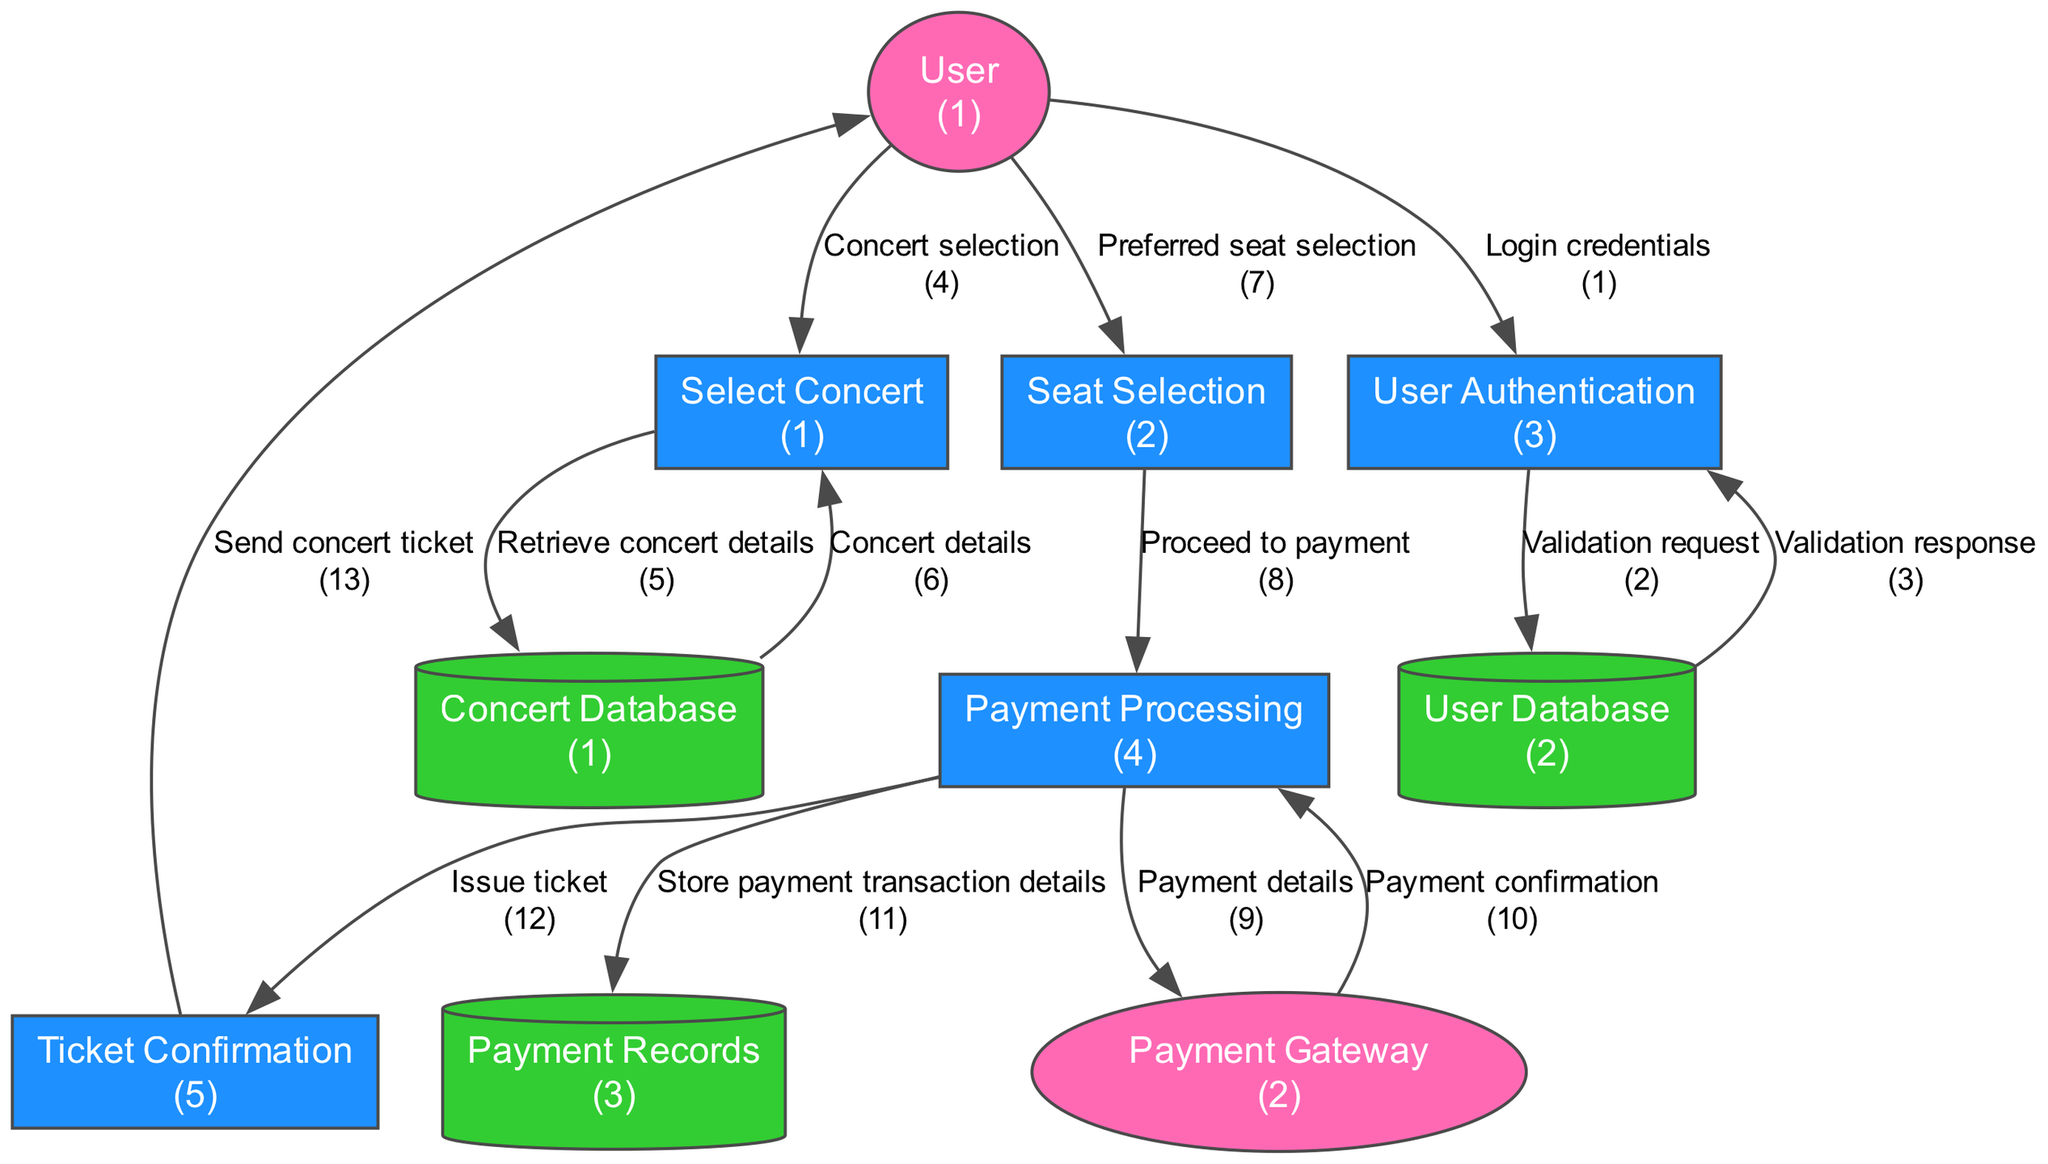What is the name of the first process in the diagram? The first process in the diagram is labeled as "Select Concert," which is identified by the process ID "1".
Answer: Select Concert How many data stores are present in the diagram? There are three data stores depicted in the diagram: Concert Database, User Database, and Payment Records.
Answer: 3 What entity is responsible for handling payment transactions? The external entity that handles payment transactions is labeled as "Payment Gateway".
Answer: Payment Gateway Which process comes after "Seat Selection"? The process that follows "Seat Selection" is "Payment Processing", denoted by process ID "4".
Answer: Payment Processing From which process does the data flow labeled 'Proceed to payment' come? The 'Proceed to payment' data flow originates from the process "Seat Selection", indicating that user selection triggers the payment process.
Answer: Seat Selection What data store holds user information? The data store that contains user information for login and registration is named "User Database".
Answer: User Database How many external entities are shown in the diagram? There are two external entities represented in the diagram: User and Payment Gateway.
Answer: 2 What is the final step in the ticket booking process? The final step in the ticket booking process is "Ticket Confirmation", which generates and sends the concert ticket to the user.
Answer: Ticket Confirmation What type of information flows from the Payment Processing to Payment Records? The information that flows from Payment Processing to Payment Records consists of payment transaction details that need to be stored securely for reference.
Answer: Store payment transaction details 